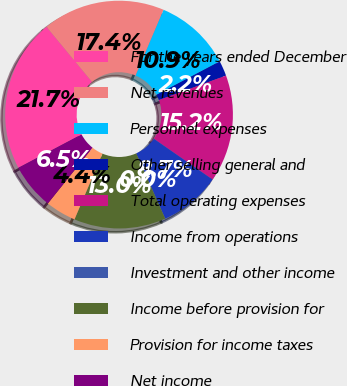<chart> <loc_0><loc_0><loc_500><loc_500><pie_chart><fcel>For the years ended December<fcel>Net revenues<fcel>Personnel expenses<fcel>Other selling general and<fcel>Total operating expenses<fcel>Income from operations<fcel>Investment and other income<fcel>Income before provision for<fcel>Provision for income taxes<fcel>Net income<nl><fcel>21.74%<fcel>17.39%<fcel>10.87%<fcel>2.17%<fcel>15.22%<fcel>8.7%<fcel>0.0%<fcel>13.04%<fcel>4.35%<fcel>6.52%<nl></chart> 